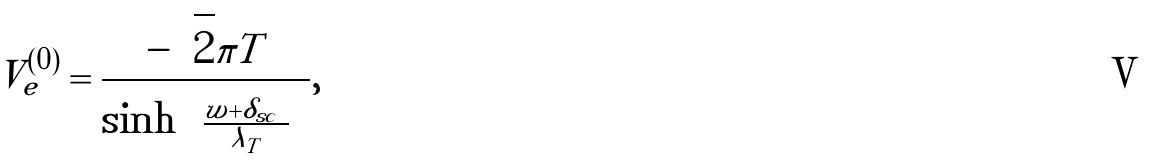Convert formula to latex. <formula><loc_0><loc_0><loc_500><loc_500>V _ { e } ^ { ( 0 ) } = \frac { - \sqrt { 2 } \pi T } { \sinh { \left ( \frac { | w | + \delta _ { s c } } { \lambda _ { T } } \right ) } } ,</formula> 